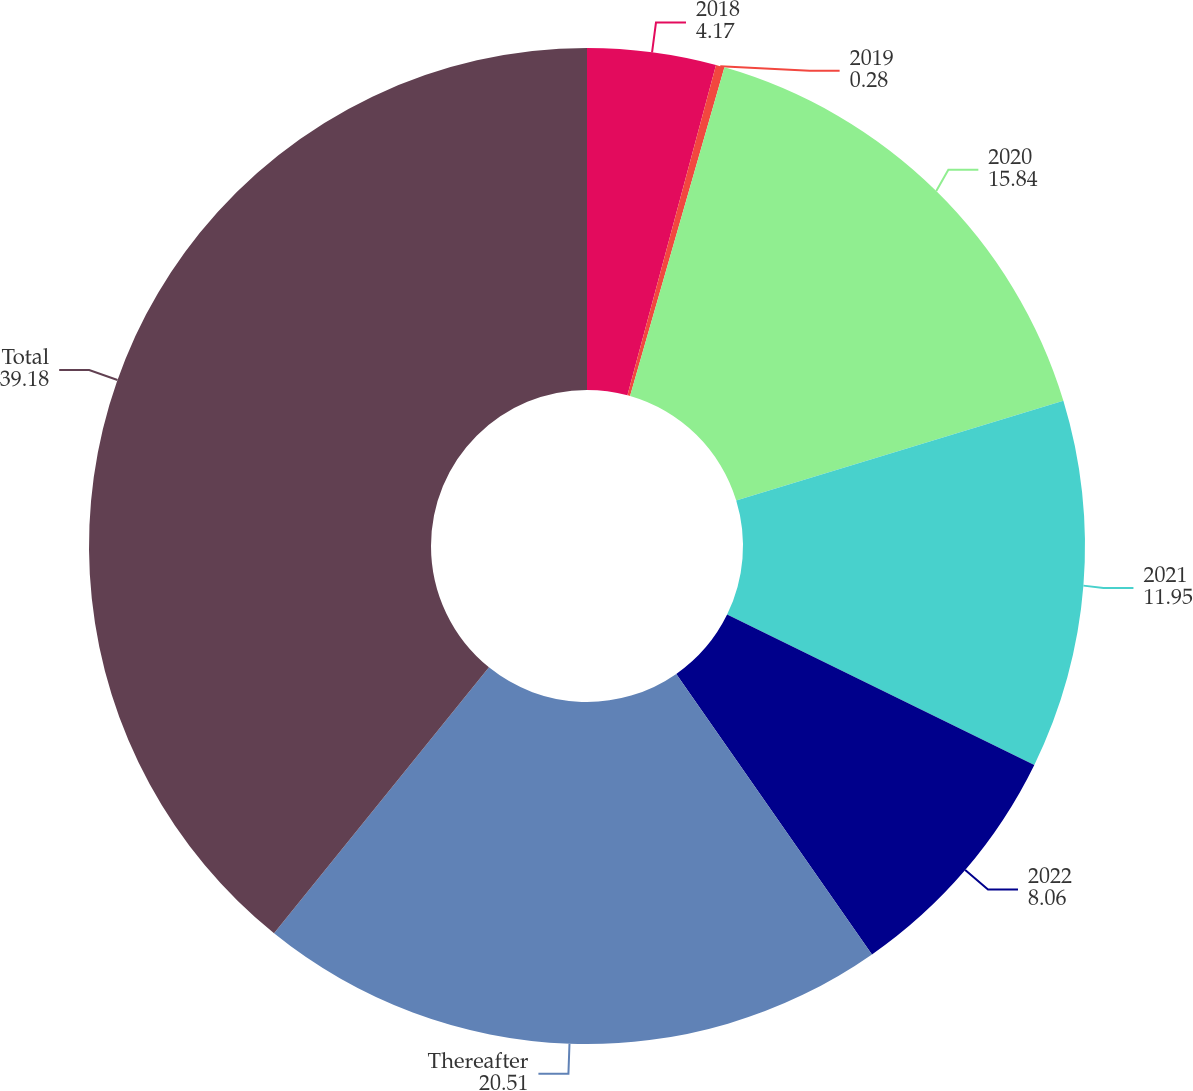Convert chart. <chart><loc_0><loc_0><loc_500><loc_500><pie_chart><fcel>2018<fcel>2019<fcel>2020<fcel>2021<fcel>2022<fcel>Thereafter<fcel>Total<nl><fcel>4.17%<fcel>0.28%<fcel>15.84%<fcel>11.95%<fcel>8.06%<fcel>20.51%<fcel>39.18%<nl></chart> 